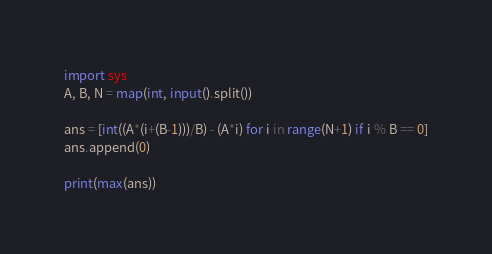<code> <loc_0><loc_0><loc_500><loc_500><_Python_>import sys
A, B, N = map(int, input().split())

ans = [int((A*(i+(B-1)))/B) - (A*i) for i in range(N+1) if i % B == 0]
ans.append(0)

print(max(ans))</code> 